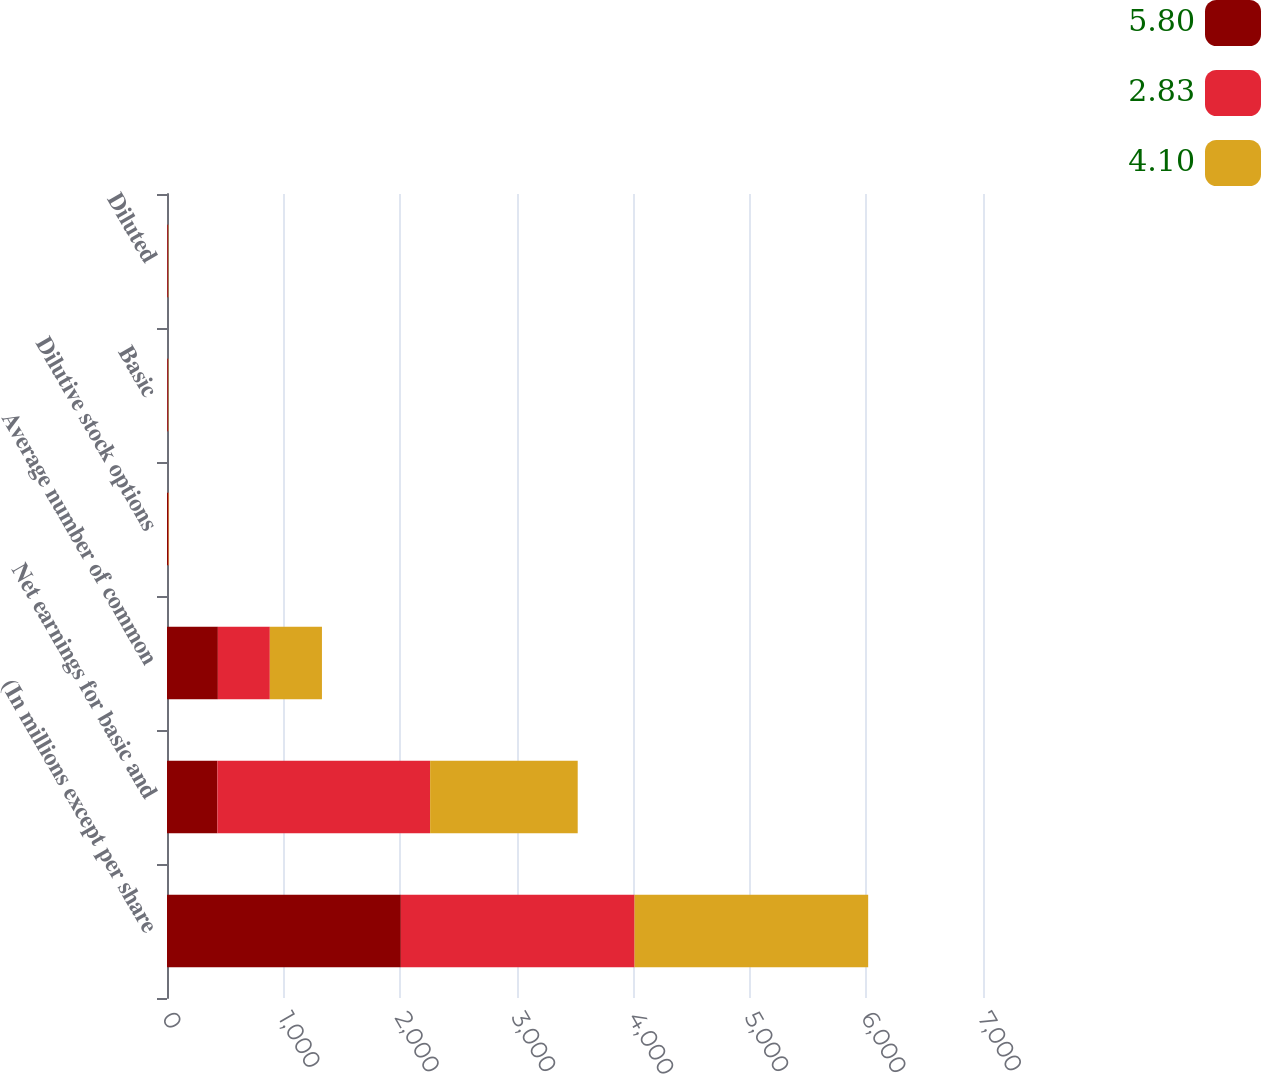Convert chart. <chart><loc_0><loc_0><loc_500><loc_500><stacked_bar_chart><ecel><fcel>(In millions except per share<fcel>Net earnings for basic and<fcel>Average number of common<fcel>Dilutive stock options<fcel>Basic<fcel>Diluted<nl><fcel>5.8<fcel>2006<fcel>432.25<fcel>436.4<fcel>8.3<fcel>5.91<fcel>5.8<nl><fcel>2.83<fcel>2005<fcel>1825<fcel>445.7<fcel>5.4<fcel>4.15<fcel>4.1<nl><fcel>4.1<fcel>2004<fcel>1266<fcel>447.1<fcel>4<fcel>2.86<fcel>2.83<nl></chart> 